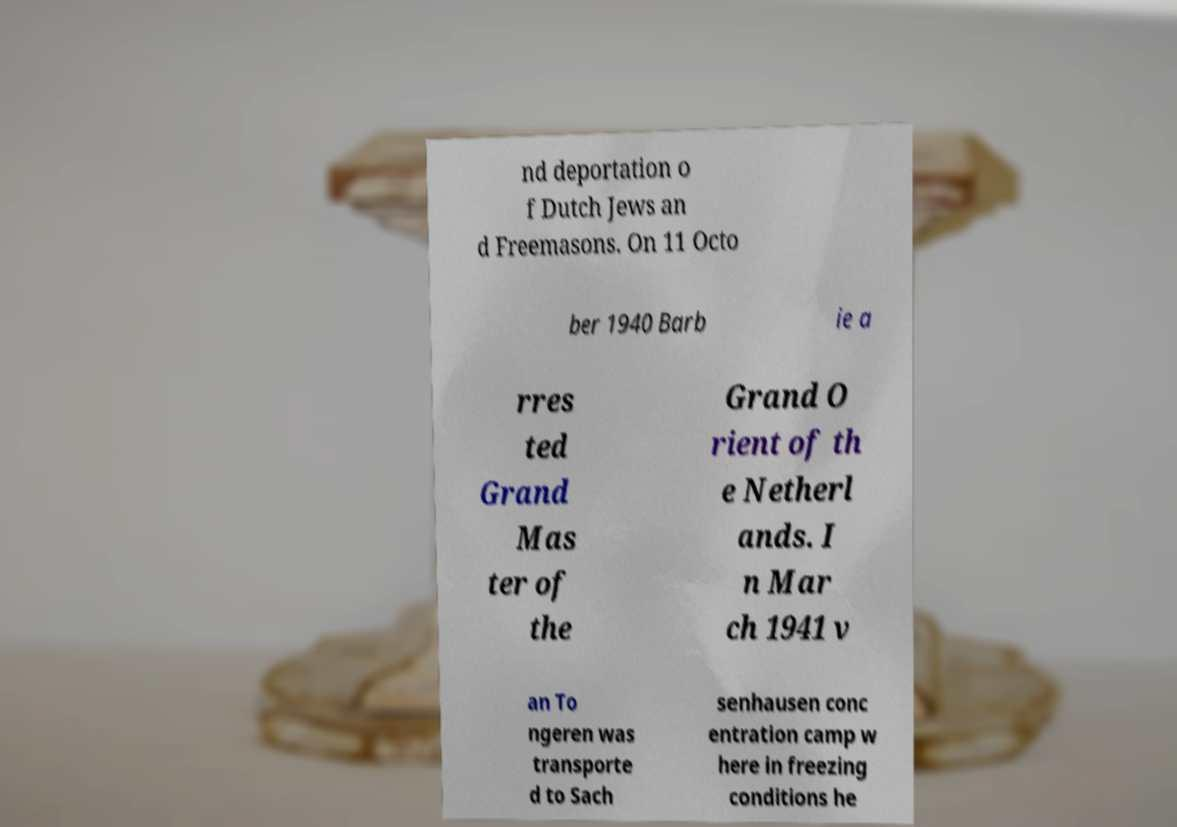Please read and relay the text visible in this image. What does it say? nd deportation o f Dutch Jews an d Freemasons. On 11 Octo ber 1940 Barb ie a rres ted Grand Mas ter of the Grand O rient of th e Netherl ands. I n Mar ch 1941 v an To ngeren was transporte d to Sach senhausen conc entration camp w here in freezing conditions he 